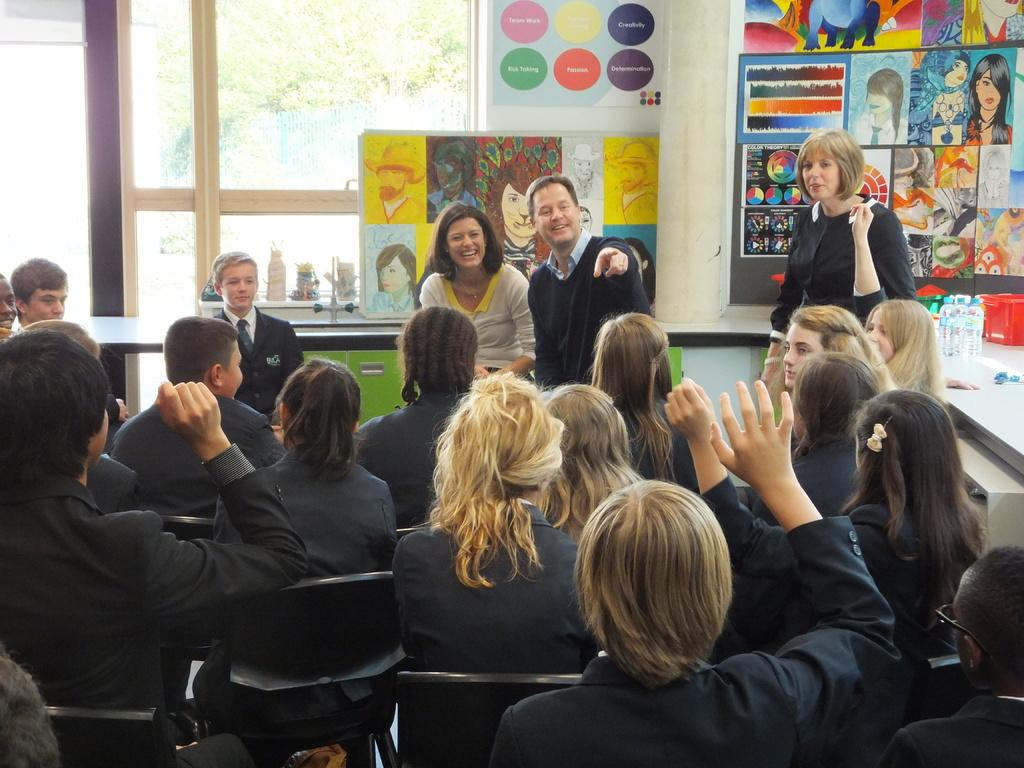How many people are sitting in the chairs in the image? There are many persons sitting in the chairs in the image. What can be seen in the background of the image? There are posters and paintings in the background, as well as a window. What type of setting is depicted in the image? The setting appears to be a classroom. How many mice can be seen running across the floor in the image? There are no mice visible in the image. What type of clouds can be seen through the window in the image? There is no mention of clouds in the image, and the window is not described in enough detail to determine if clouds are visible. 